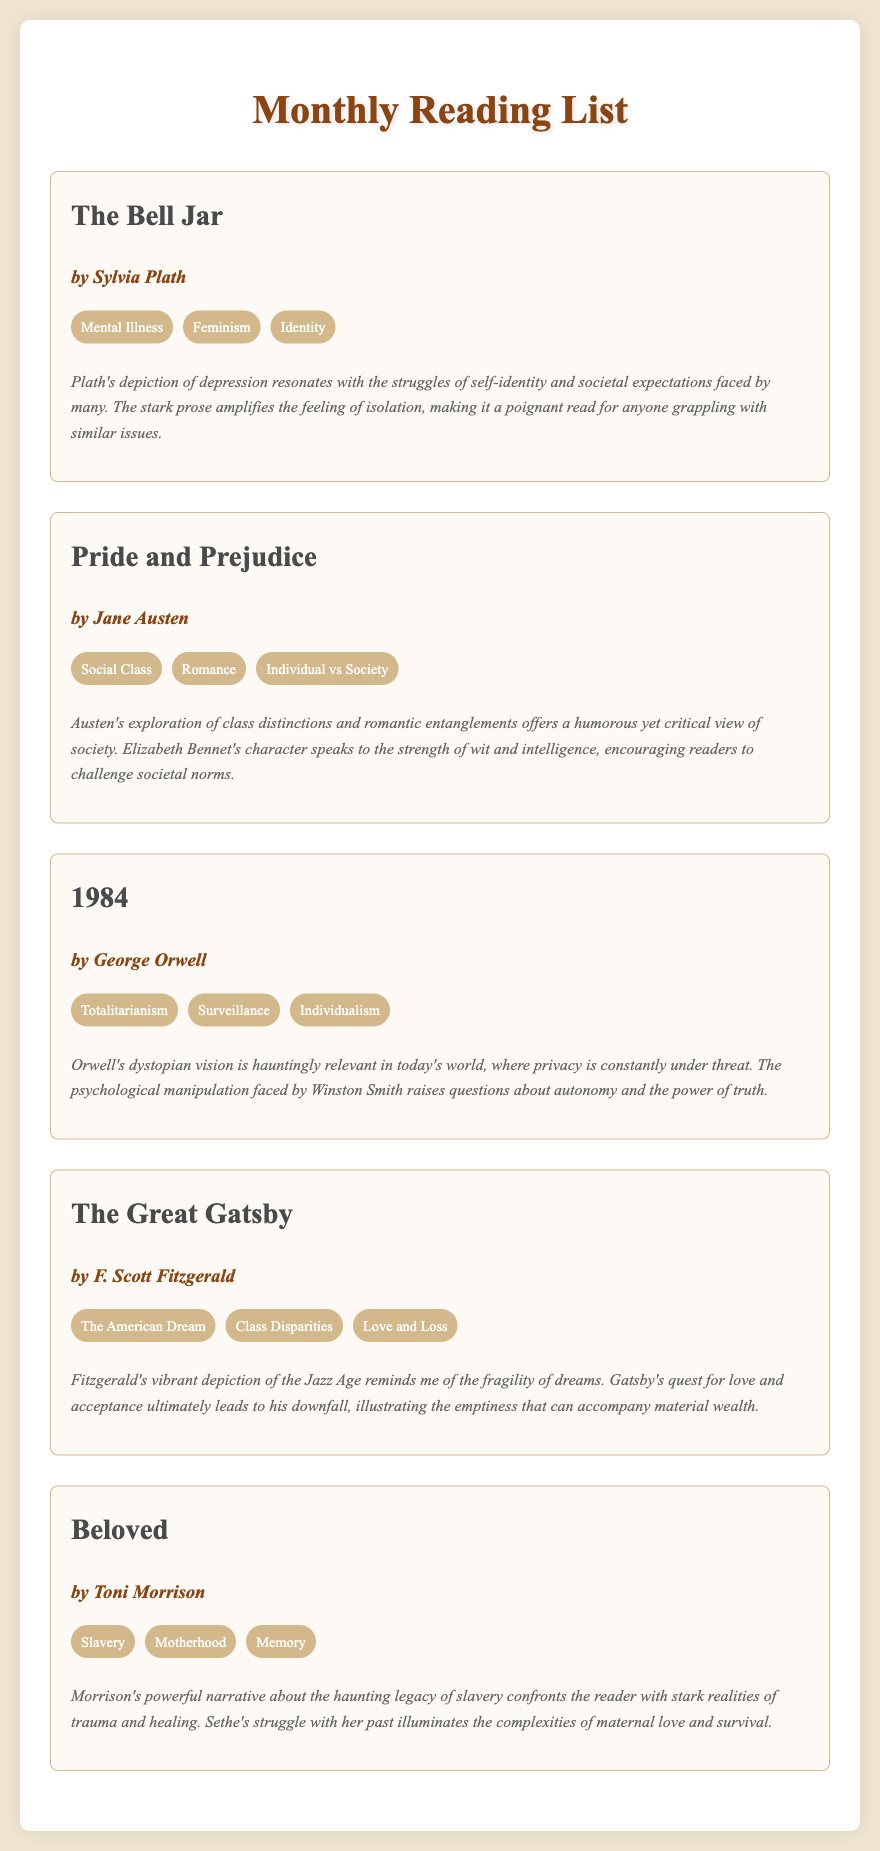What is the title of the first book? The title of the first book is stated prominently in the document as "The Bell Jar."
Answer: The Bell Jar Who is the author of "Pride and Prejudice"? The author of "Pride and Prejudice" is listed as Jane Austen.
Answer: Jane Austen What theme is associated with "1984"? The themes listed for "1984" include Totalitarianism, Surveillance, and Individualism.
Answer: Totalitarianism Which book explores the theme of motherhood? The theme of motherhood is evident in the book "Beloved" by Toni Morrison.
Answer: Beloved What does Gatsby's quest in "The Great Gatsby" ultimately lead to? The reflection notes that Gatsby's quest for love and acceptance ultimately leads to his downfall.
Answer: His downfall How many books are listed in the monthly reading list? The document contains five distinct books in the monthly reading list.
Answer: Five What reflection is made about "The Bell Jar"? The reflection discusses Plath's depiction of depression and issues of self-identity.
Answer: Plath's depiction of depression Which book’s theme includes the concept of the American Dream? The theme of the American Dream is associated with "The Great Gatsby."
Answer: The Great Gatsby What is the primary focus of "Beloved"? The primary focus of "Beloved" revolves around the haunting legacy of slavery.
Answer: Haunting legacy of slavery 